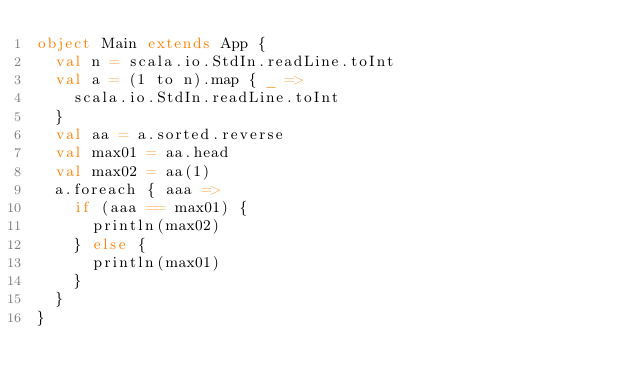Convert code to text. <code><loc_0><loc_0><loc_500><loc_500><_Scala_>object Main extends App {
  val n = scala.io.StdIn.readLine.toInt
  val a = (1 to n).map { _ =>
    scala.io.StdIn.readLine.toInt
  }
  val aa = a.sorted.reverse
  val max01 = aa.head
  val max02 = aa(1)
  a.foreach { aaa =>
    if (aaa == max01) {
      println(max02)
    } else {
      println(max01)
    }
  }
}</code> 